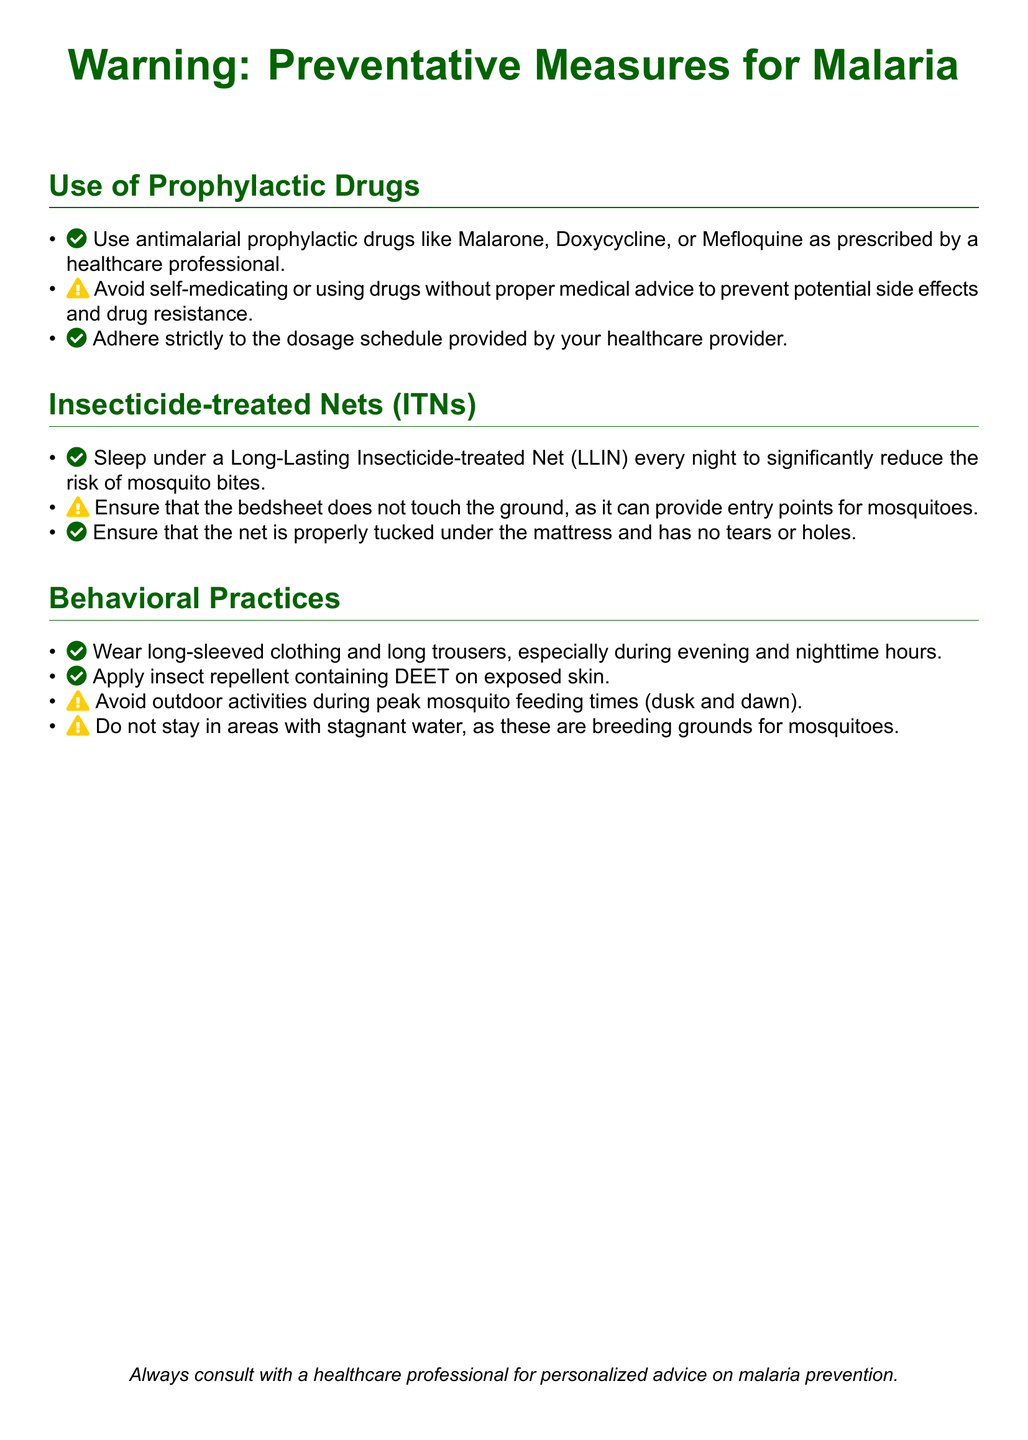what are the recommended prophylactic drugs for malaria? The document lists Malarone, Doxycycline, or Mefloquine as recommended prophylactic drugs for malaria.
Answer: Malarone, Doxycycline, Mefloquine what should you avoid when considering prophylactic drugs? The document advises against self-medicating or using drugs without proper medical advice to prevent potential side effects and drug resistance.
Answer: Self-medicating, improper use how should insecticide-treated nets be used? The document recommends sleeping under a Long-Lasting Insecticide-treated Net (LLIN) every night to significantly reduce the risk of mosquito bites.
Answer: Every night what is a key behavioral practice to prevent mosquito bites? The document suggests wearing long-sleeved clothing and applying insect repellent containing DEET on exposed skin as key practices.
Answer: Long-sleeved clothing, DEET when should outdoor activities be avoided? According to the document, outdoor activities should be avoided during peak mosquito feeding times, which are dusk and dawn.
Answer: Dusk and dawn 